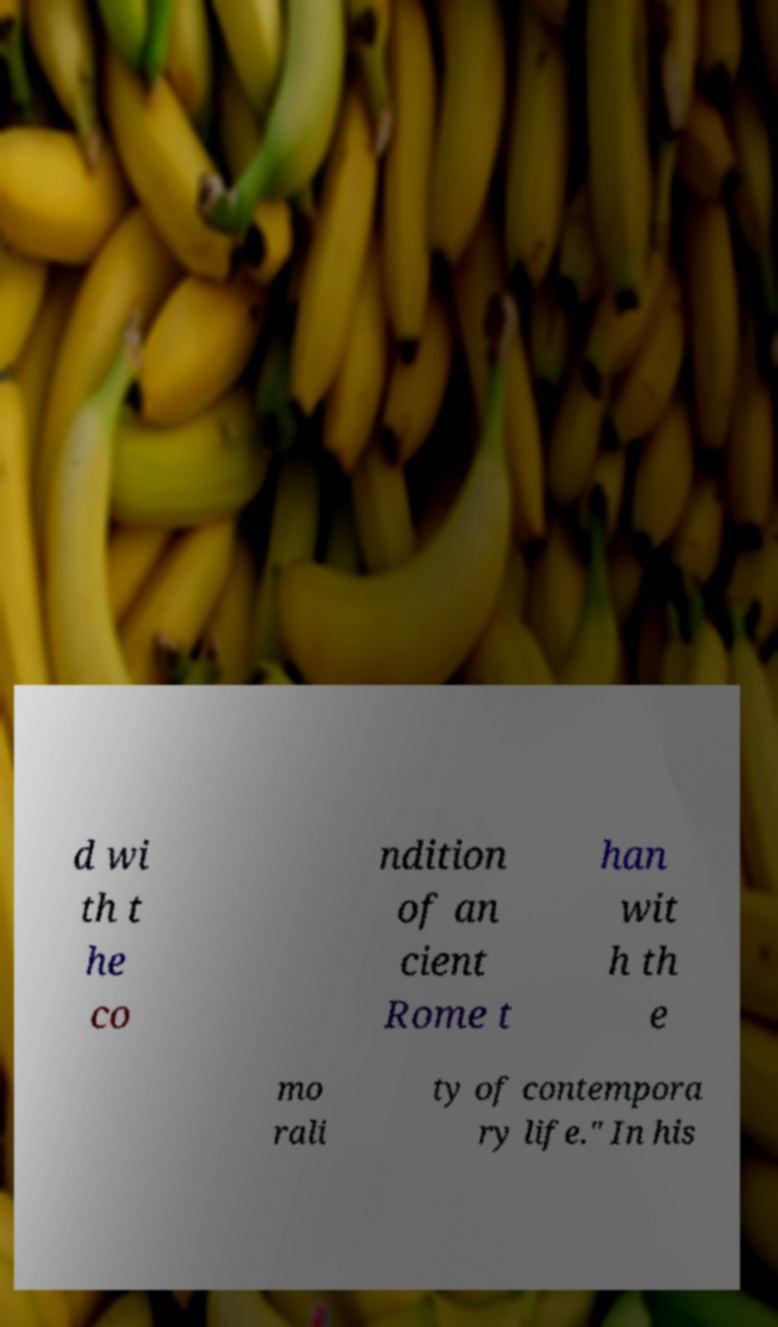Can you accurately transcribe the text from the provided image for me? d wi th t he co ndition of an cient Rome t han wit h th e mo rali ty of contempora ry life." In his 